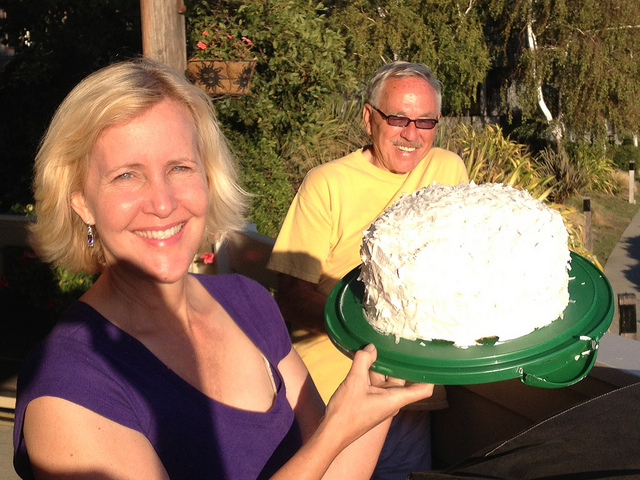What occasion might they be celebrating? Based on the size of the cake and the joyful expressions, they could be celebrating a birthday, an anniversary, or another significant personal milestone. 